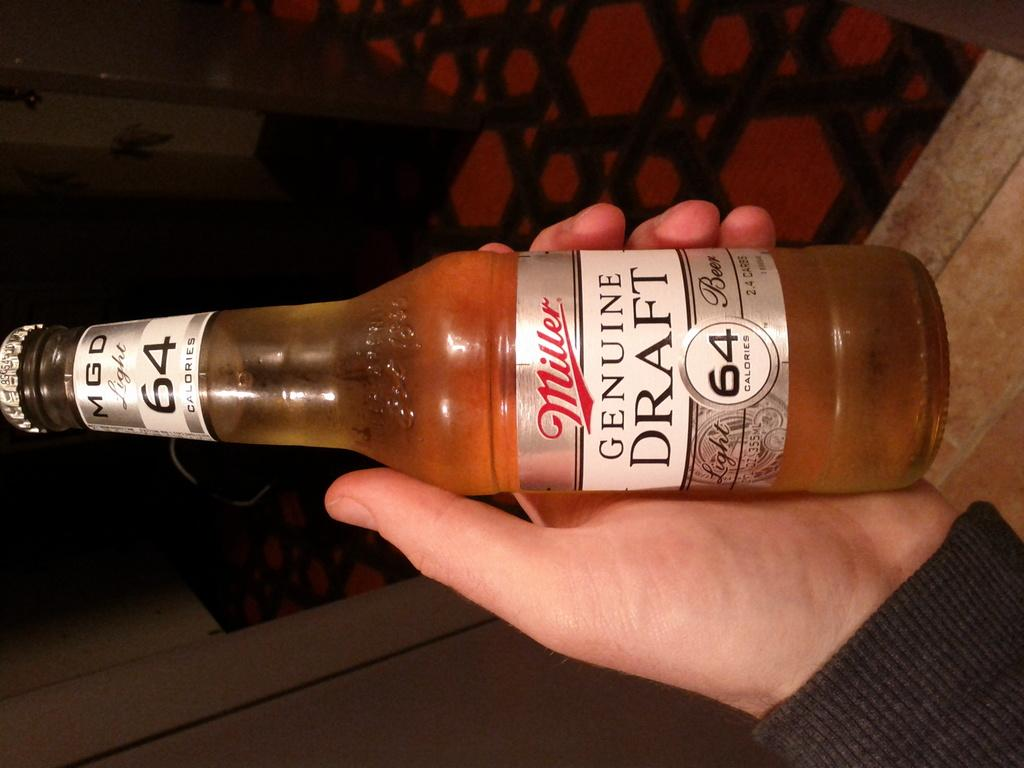Provide a one-sentence caption for the provided image. Person holding a Miller genuine draft beer with 64 calories. 